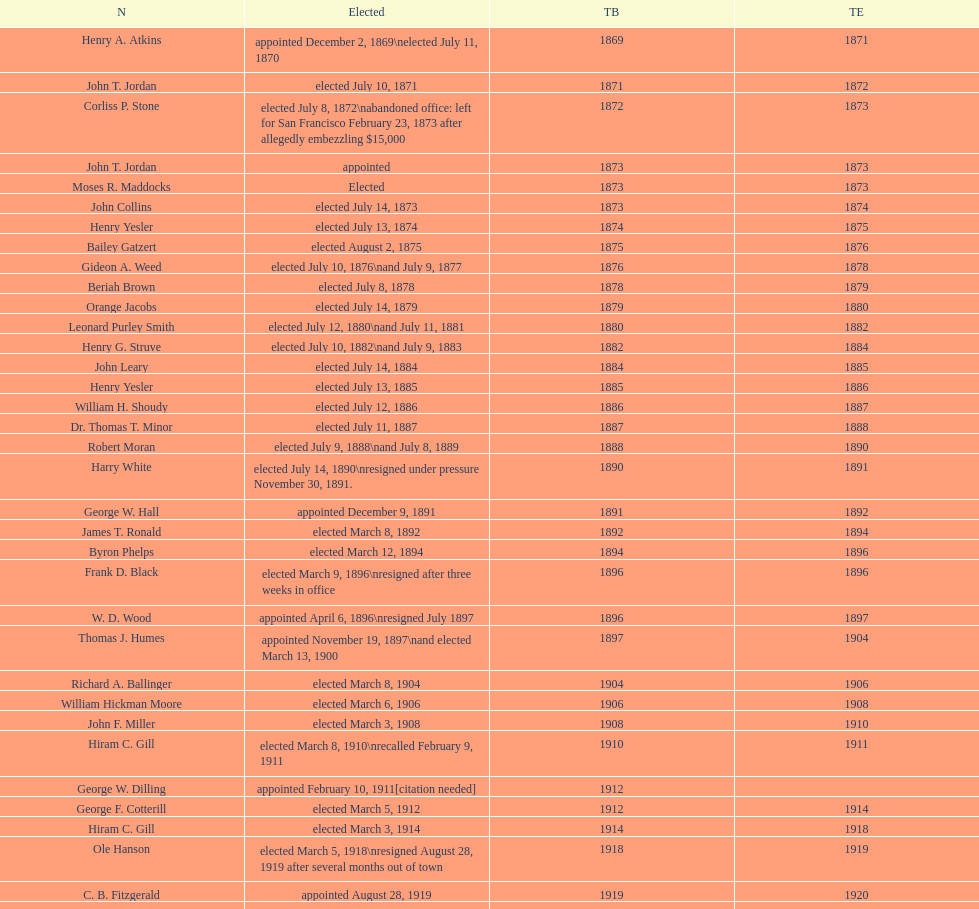Who started their tenure in 1890? Harry White. 